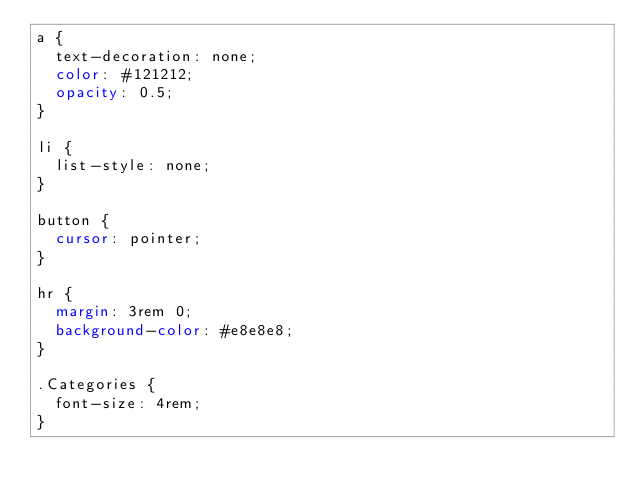<code> <loc_0><loc_0><loc_500><loc_500><_CSS_>a {
  text-decoration: none;
  color: #121212;
  opacity: 0.5;
}

li {
  list-style: none;
}

button {
  cursor: pointer;
}

hr {
  margin: 3rem 0;
  background-color: #e8e8e8;
}

.Categories {
  font-size: 4rem;
}
</code> 